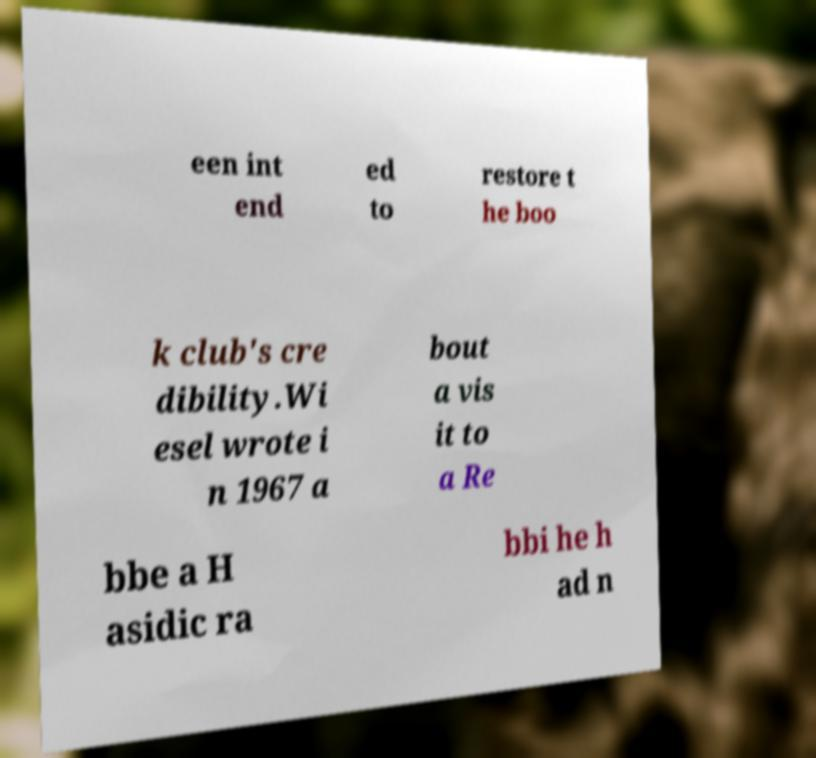Could you extract and type out the text from this image? een int end ed to restore t he boo k club's cre dibility.Wi esel wrote i n 1967 a bout a vis it to a Re bbe a H asidic ra bbi he h ad n 